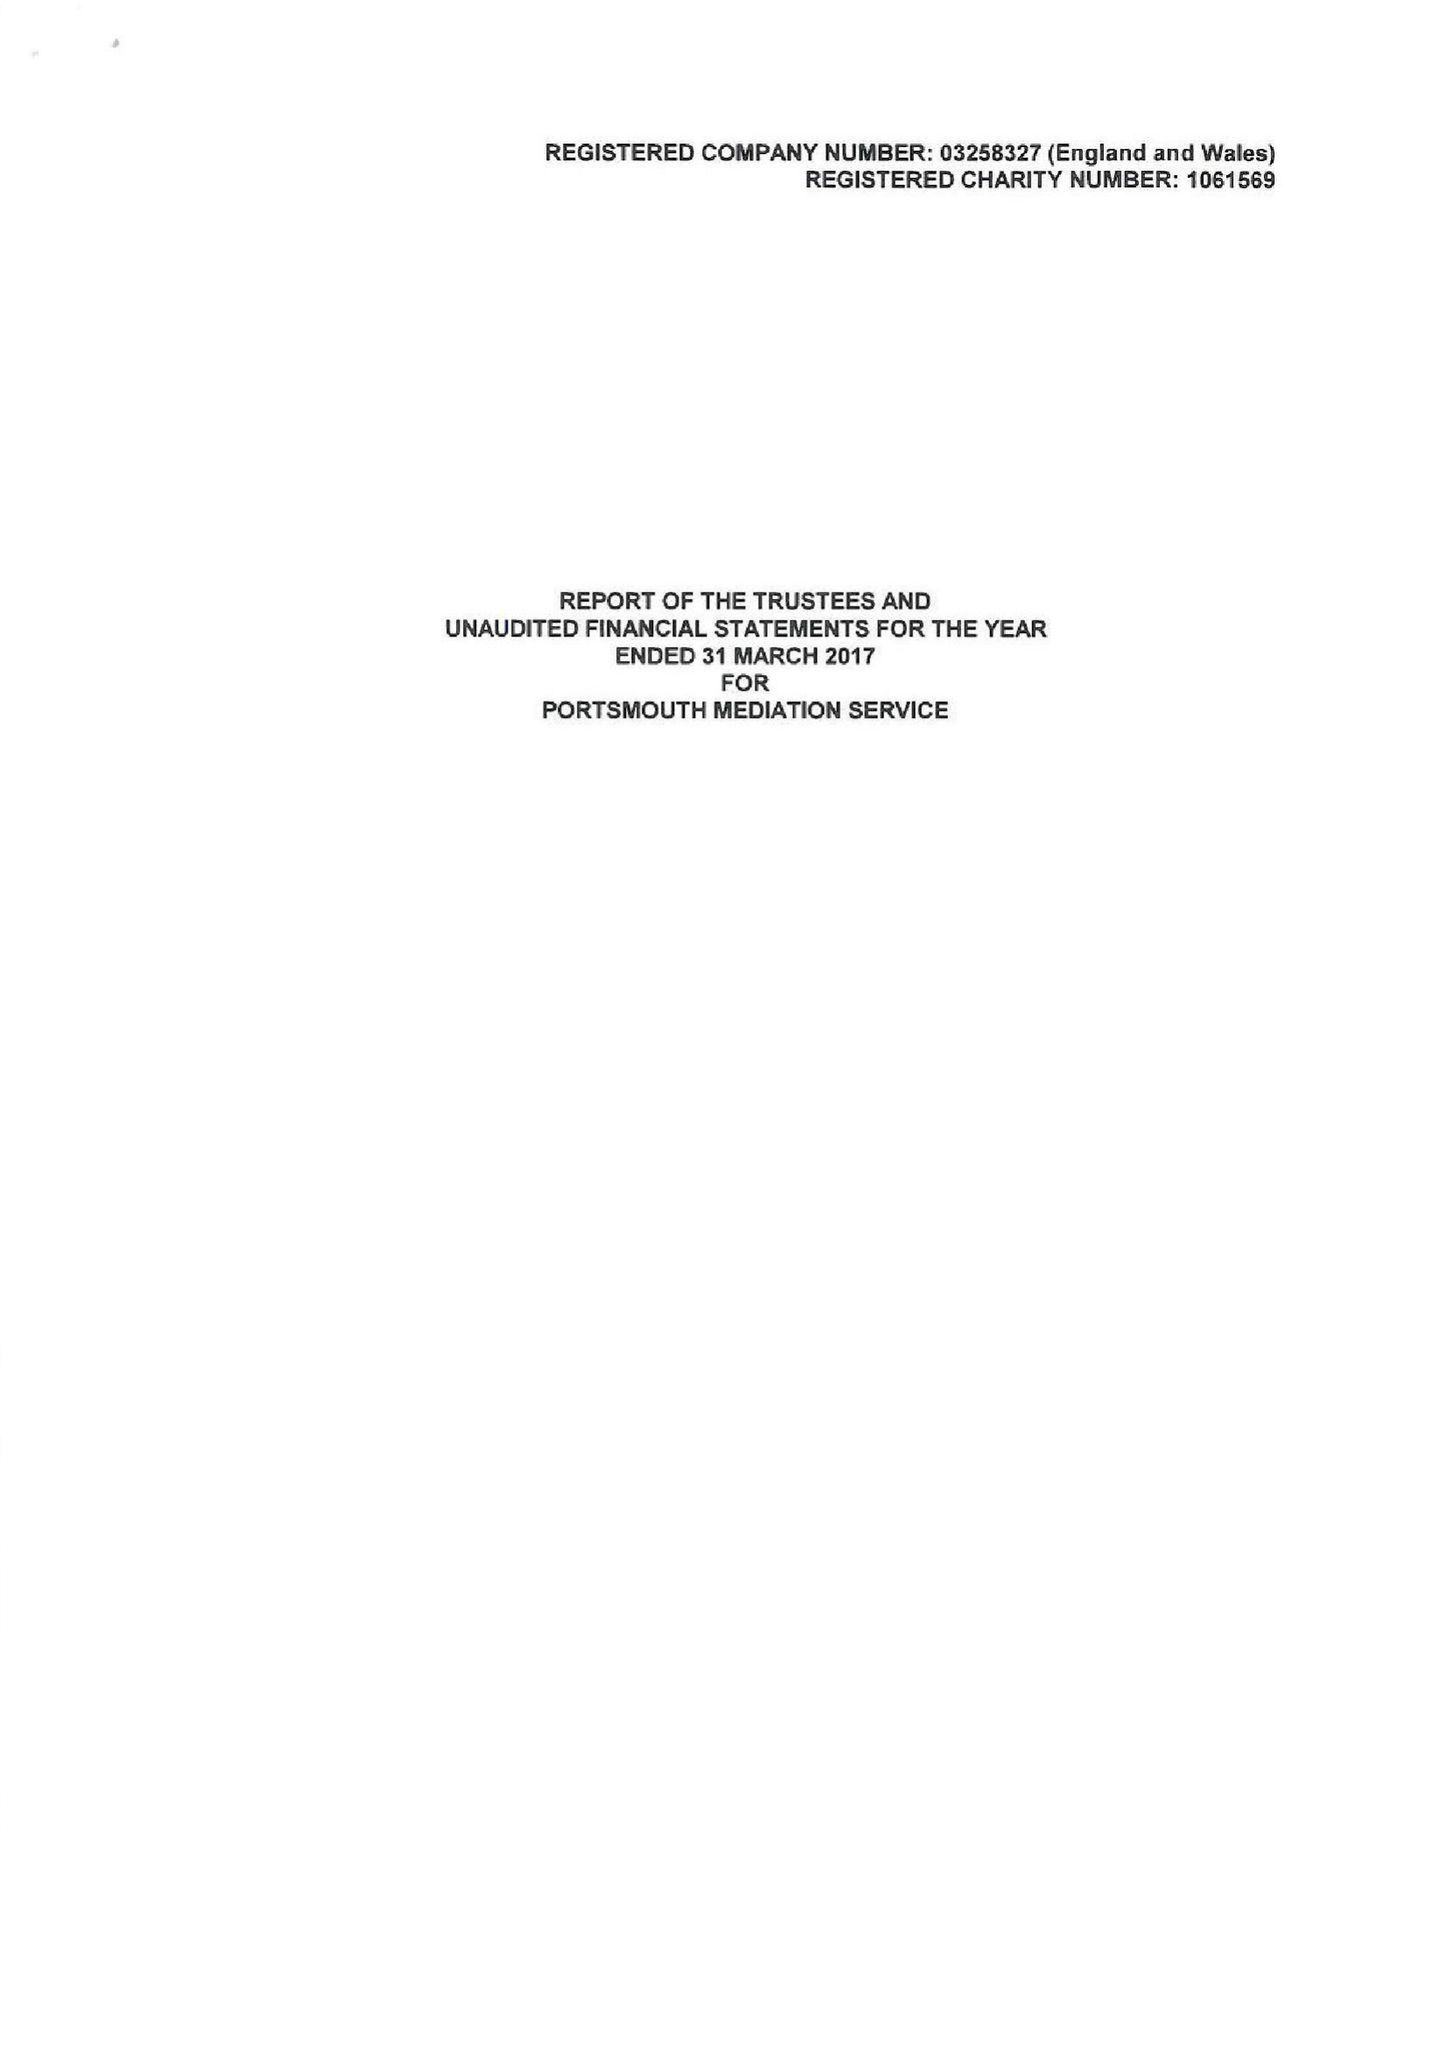What is the value for the income_annually_in_british_pounds?
Answer the question using a single word or phrase. 149807.00 